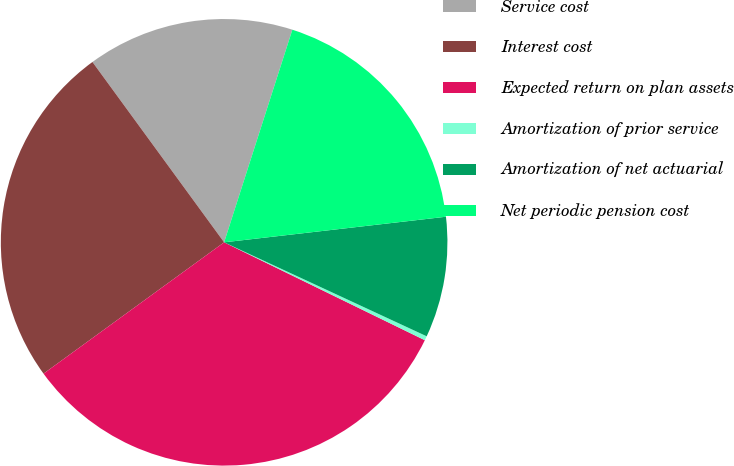Convert chart. <chart><loc_0><loc_0><loc_500><loc_500><pie_chart><fcel>Service cost<fcel>Interest cost<fcel>Expected return on plan assets<fcel>Amortization of prior service<fcel>Amortization of net actuarial<fcel>Net periodic pension cost<nl><fcel>14.98%<fcel>24.97%<fcel>32.77%<fcel>0.31%<fcel>8.74%<fcel>18.23%<nl></chart> 